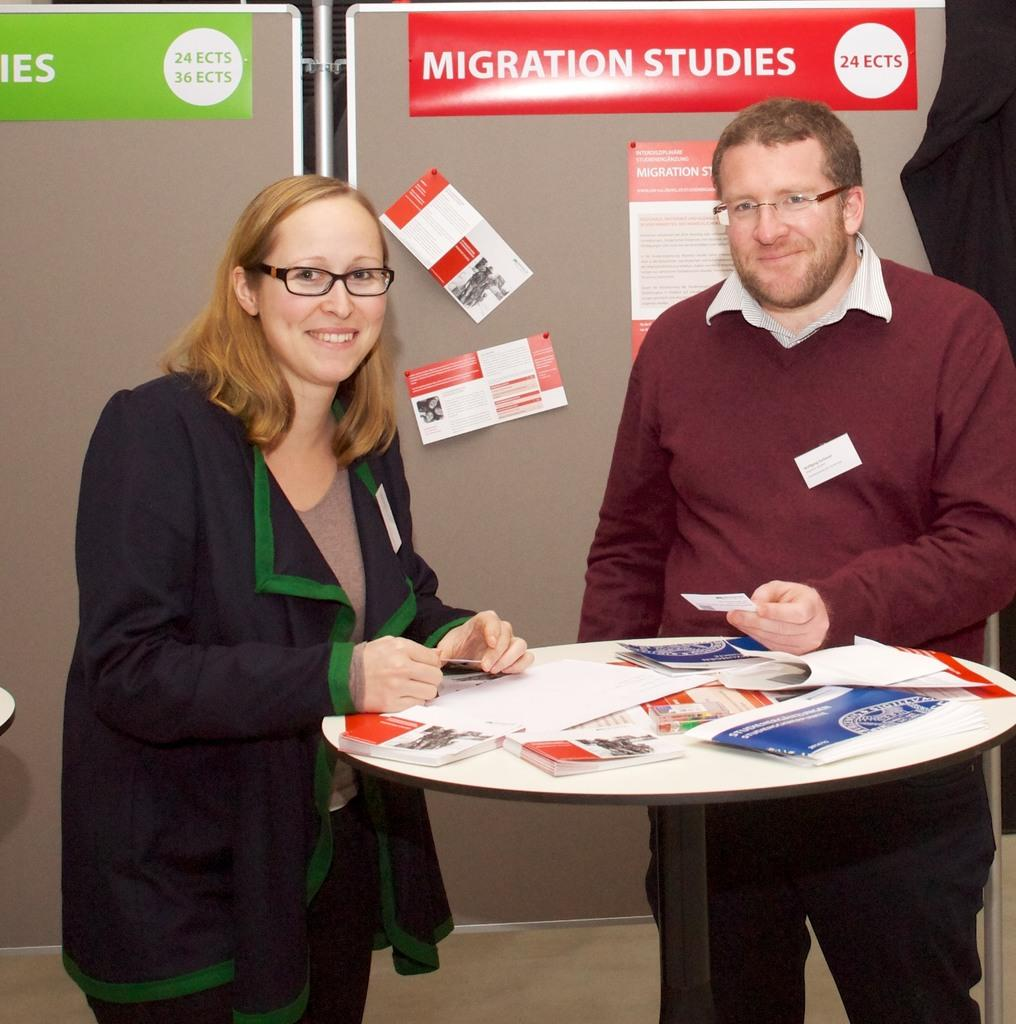How many people are present in the image? There are 2 people standing in the image. What are the people wearing? The people are wearing spectacles. What object can be seen in the image besides the people? There is a table in the image. What is on the table? There are pamphlets on the table, and some of them are attached at the back. What type of roof can be seen in the image? There is no roof visible in the image. Can you describe the cup that is being used by one of the people in the image? There is no cup present in the image. 